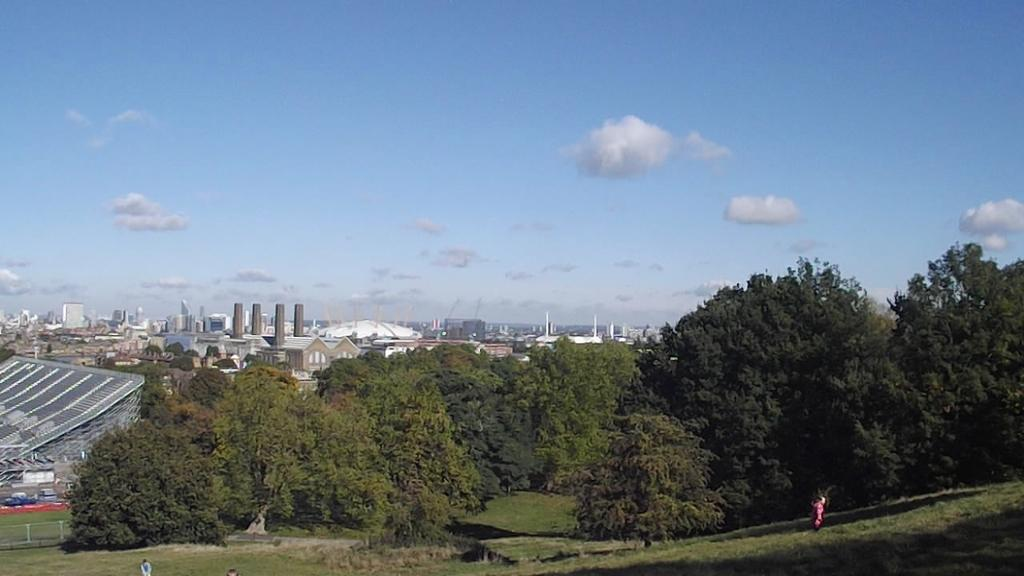What type of structures can be seen in the image? There are buildings in the image. What natural elements are present in the image? There are trees and grass in the image. What part of the natural environment is visible in the image? The sky is visible in the image. What can be observed in the sky? There are clouds in the sky. What type of rhythm can be heard coming from the buildings in the image? There is no sound or rhythm present in the image; it is a still image of buildings, trees, grass, sky, and clouds. 